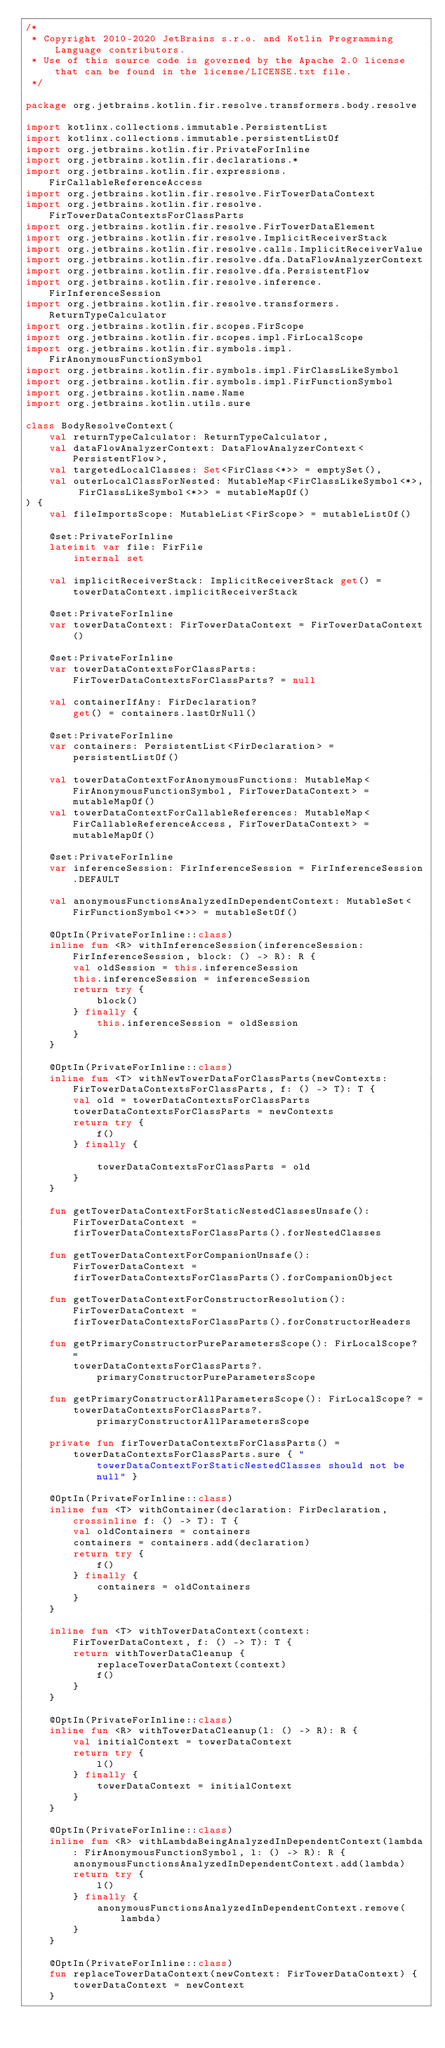Convert code to text. <code><loc_0><loc_0><loc_500><loc_500><_Kotlin_>/*
 * Copyright 2010-2020 JetBrains s.r.o. and Kotlin Programming Language contributors.
 * Use of this source code is governed by the Apache 2.0 license that can be found in the license/LICENSE.txt file.
 */

package org.jetbrains.kotlin.fir.resolve.transformers.body.resolve

import kotlinx.collections.immutable.PersistentList
import kotlinx.collections.immutable.persistentListOf
import org.jetbrains.kotlin.fir.PrivateForInline
import org.jetbrains.kotlin.fir.declarations.*
import org.jetbrains.kotlin.fir.expressions.FirCallableReferenceAccess
import org.jetbrains.kotlin.fir.resolve.FirTowerDataContext
import org.jetbrains.kotlin.fir.resolve.FirTowerDataContextsForClassParts
import org.jetbrains.kotlin.fir.resolve.FirTowerDataElement
import org.jetbrains.kotlin.fir.resolve.ImplicitReceiverStack
import org.jetbrains.kotlin.fir.resolve.calls.ImplicitReceiverValue
import org.jetbrains.kotlin.fir.resolve.dfa.DataFlowAnalyzerContext
import org.jetbrains.kotlin.fir.resolve.dfa.PersistentFlow
import org.jetbrains.kotlin.fir.resolve.inference.FirInferenceSession
import org.jetbrains.kotlin.fir.resolve.transformers.ReturnTypeCalculator
import org.jetbrains.kotlin.fir.scopes.FirScope
import org.jetbrains.kotlin.fir.scopes.impl.FirLocalScope
import org.jetbrains.kotlin.fir.symbols.impl.FirAnonymousFunctionSymbol
import org.jetbrains.kotlin.fir.symbols.impl.FirClassLikeSymbol
import org.jetbrains.kotlin.fir.symbols.impl.FirFunctionSymbol
import org.jetbrains.kotlin.name.Name
import org.jetbrains.kotlin.utils.sure

class BodyResolveContext(
    val returnTypeCalculator: ReturnTypeCalculator,
    val dataFlowAnalyzerContext: DataFlowAnalyzerContext<PersistentFlow>,
    val targetedLocalClasses: Set<FirClass<*>> = emptySet(),
    val outerLocalClassForNested: MutableMap<FirClassLikeSymbol<*>, FirClassLikeSymbol<*>> = mutableMapOf()
) {
    val fileImportsScope: MutableList<FirScope> = mutableListOf()

    @set:PrivateForInline
    lateinit var file: FirFile
        internal set

    val implicitReceiverStack: ImplicitReceiverStack get() = towerDataContext.implicitReceiverStack

    @set:PrivateForInline
    var towerDataContext: FirTowerDataContext = FirTowerDataContext()

    @set:PrivateForInline
    var towerDataContextsForClassParts: FirTowerDataContextsForClassParts? = null

    val containerIfAny: FirDeclaration?
        get() = containers.lastOrNull()

    @set:PrivateForInline
    var containers: PersistentList<FirDeclaration> = persistentListOf()

    val towerDataContextForAnonymousFunctions: MutableMap<FirAnonymousFunctionSymbol, FirTowerDataContext> = mutableMapOf()
    val towerDataContextForCallableReferences: MutableMap<FirCallableReferenceAccess, FirTowerDataContext> = mutableMapOf()

    @set:PrivateForInline
    var inferenceSession: FirInferenceSession = FirInferenceSession.DEFAULT

    val anonymousFunctionsAnalyzedInDependentContext: MutableSet<FirFunctionSymbol<*>> = mutableSetOf()

    @OptIn(PrivateForInline::class)
    inline fun <R> withInferenceSession(inferenceSession: FirInferenceSession, block: () -> R): R {
        val oldSession = this.inferenceSession
        this.inferenceSession = inferenceSession
        return try {
            block()
        } finally {
            this.inferenceSession = oldSession
        }
    }

    @OptIn(PrivateForInline::class)
    inline fun <T> withNewTowerDataForClassParts(newContexts: FirTowerDataContextsForClassParts, f: () -> T): T {
        val old = towerDataContextsForClassParts
        towerDataContextsForClassParts = newContexts
        return try {
            f()
        } finally {

            towerDataContextsForClassParts = old
        }
    }

    fun getTowerDataContextForStaticNestedClassesUnsafe(): FirTowerDataContext =
        firTowerDataContextsForClassParts().forNestedClasses

    fun getTowerDataContextForCompanionUnsafe(): FirTowerDataContext =
        firTowerDataContextsForClassParts().forCompanionObject

    fun getTowerDataContextForConstructorResolution(): FirTowerDataContext =
        firTowerDataContextsForClassParts().forConstructorHeaders

    fun getPrimaryConstructorPureParametersScope(): FirLocalScope? =
        towerDataContextsForClassParts?.primaryConstructorPureParametersScope

    fun getPrimaryConstructorAllParametersScope(): FirLocalScope? =
        towerDataContextsForClassParts?.primaryConstructorAllParametersScope

    private fun firTowerDataContextsForClassParts() =
        towerDataContextsForClassParts.sure { "towerDataContextForStaticNestedClasses should not be null" }

    @OptIn(PrivateForInline::class)
    inline fun <T> withContainer(declaration: FirDeclaration, crossinline f: () -> T): T {
        val oldContainers = containers
        containers = containers.add(declaration)
        return try {
            f()
        } finally {
            containers = oldContainers
        }
    }

    inline fun <T> withTowerDataContext(context: FirTowerDataContext, f: () -> T): T {
        return withTowerDataCleanup {
            replaceTowerDataContext(context)
            f()
        }
    }

    @OptIn(PrivateForInline::class)
    inline fun <R> withTowerDataCleanup(l: () -> R): R {
        val initialContext = towerDataContext
        return try {
            l()
        } finally {
            towerDataContext = initialContext
        }
    }

    @OptIn(PrivateForInline::class)
    inline fun <R> withLambdaBeingAnalyzedInDependentContext(lambda: FirAnonymousFunctionSymbol, l: () -> R): R {
        anonymousFunctionsAnalyzedInDependentContext.add(lambda)
        return try {
            l()
        } finally {
            anonymousFunctionsAnalyzedInDependentContext.remove(lambda)
        }
    }

    @OptIn(PrivateForInline::class)
    fun replaceTowerDataContext(newContext: FirTowerDataContext) {
        towerDataContext = newContext
    }
</code> 